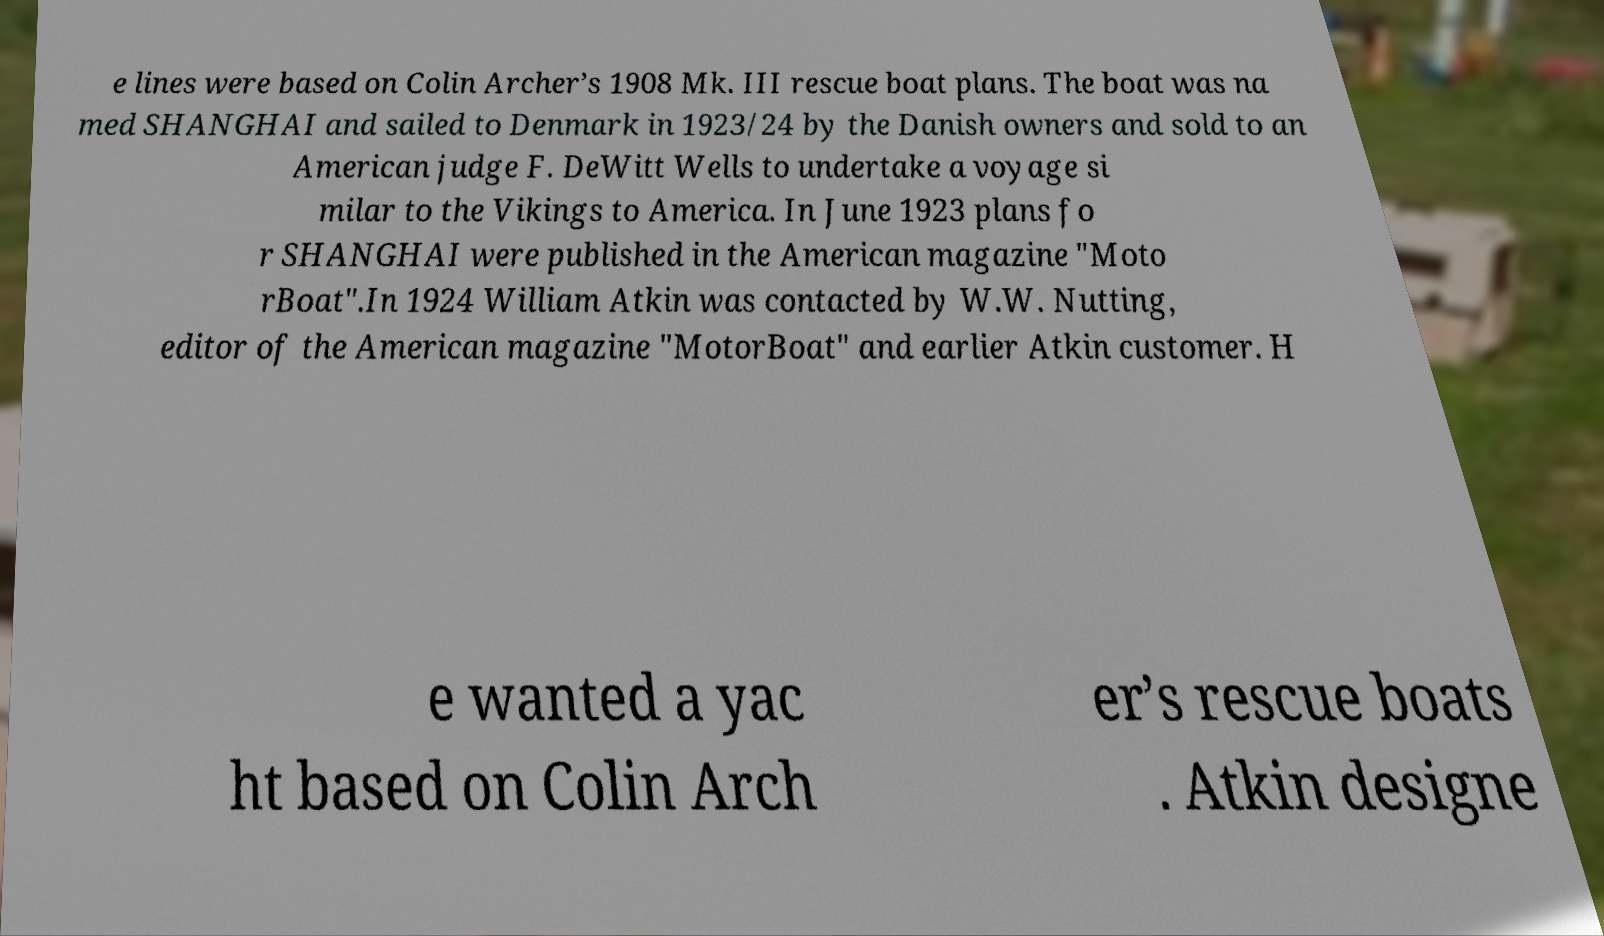There's text embedded in this image that I need extracted. Can you transcribe it verbatim? e lines were based on Colin Archer’s 1908 Mk. III rescue boat plans. The boat was na med SHANGHAI and sailed to Denmark in 1923/24 by the Danish owners and sold to an American judge F. DeWitt Wells to undertake a voyage si milar to the Vikings to America. In June 1923 plans fo r SHANGHAI were published in the American magazine "Moto rBoat".In 1924 William Atkin was contacted by W.W. Nutting, editor of the American magazine "MotorBoat" and earlier Atkin customer. H e wanted a yac ht based on Colin Arch er’s rescue boats . Atkin designe 